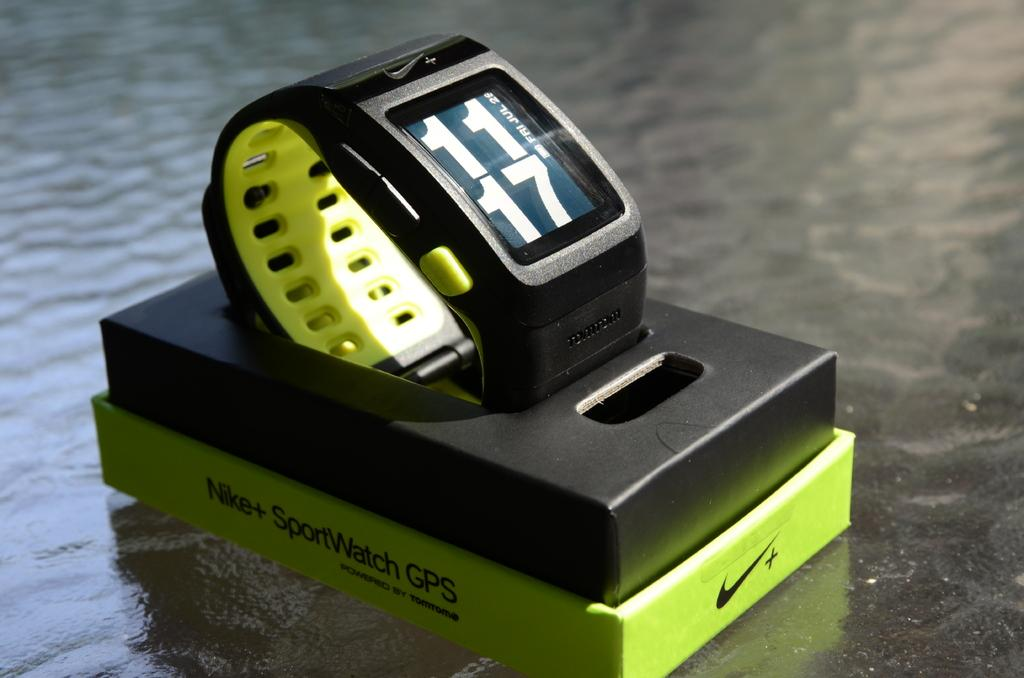<image>
Describe the image concisely. the numbers 11 and 17 are on some kind of watch 